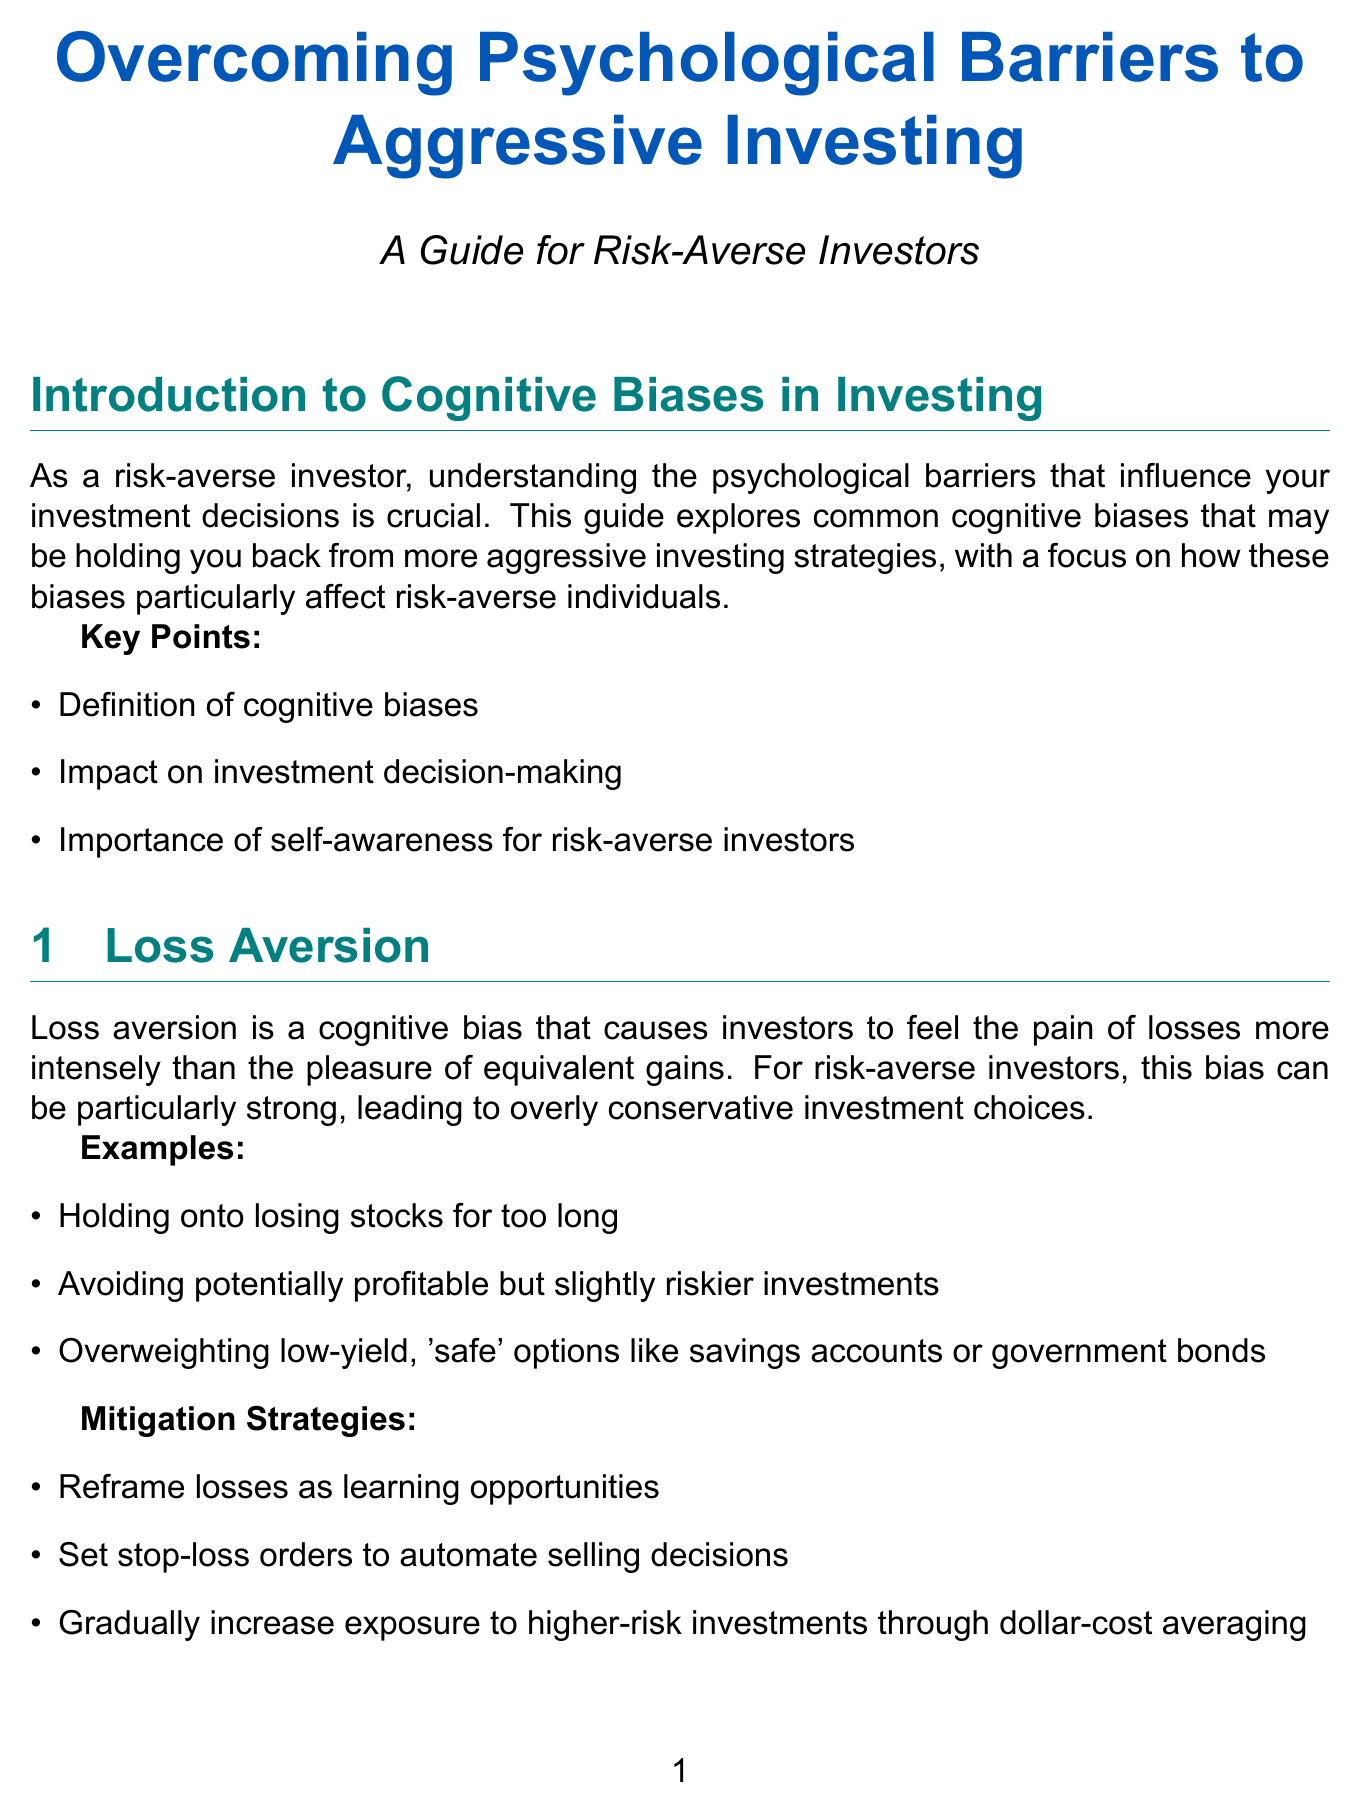What is the primary focus of this guide? The primary focus of this guide is understanding cognitive biases that affect risk-averse investors' decisions.
Answer: Cognitive biases What cognitive bias makes investors feel loss more than gain? Loss aversion is the cognitive bias that makes investors feel loss more than gain.
Answer: Loss aversion What strategy can help mitigate status quo bias? One effective strategy to mitigate status quo bias is to schedule regular portfolio reviews.
Answer: Schedule regular portfolio reviews How many case studies are presented in the document? The document presents two case studies of investors who transitioned from risk-averse to balanced investing.
Answer: Two Who is the first case study about? The first case study is about Sarah Chen, a 42-year-old software engineer.
Answer: Sarah Chen What percentage of stocks did Sarah Chen transition to in her portfolio? Sarah Chen transitioned to a 60/40 stock/bond portfolio.
Answer: 60/40 What is one recommended technology strategy mentioned for risk-averse investors? Using robo-advisors like Betterment or Wealthfront is a recommended technology strategy.
Answer: Robo-advisors What is the term for the bias where investors prefer familiar strategies? The term for this bias is status quo bias.
Answer: Status quo bias 